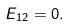Convert formula to latex. <formula><loc_0><loc_0><loc_500><loc_500>E _ { 1 2 } = 0 .</formula> 